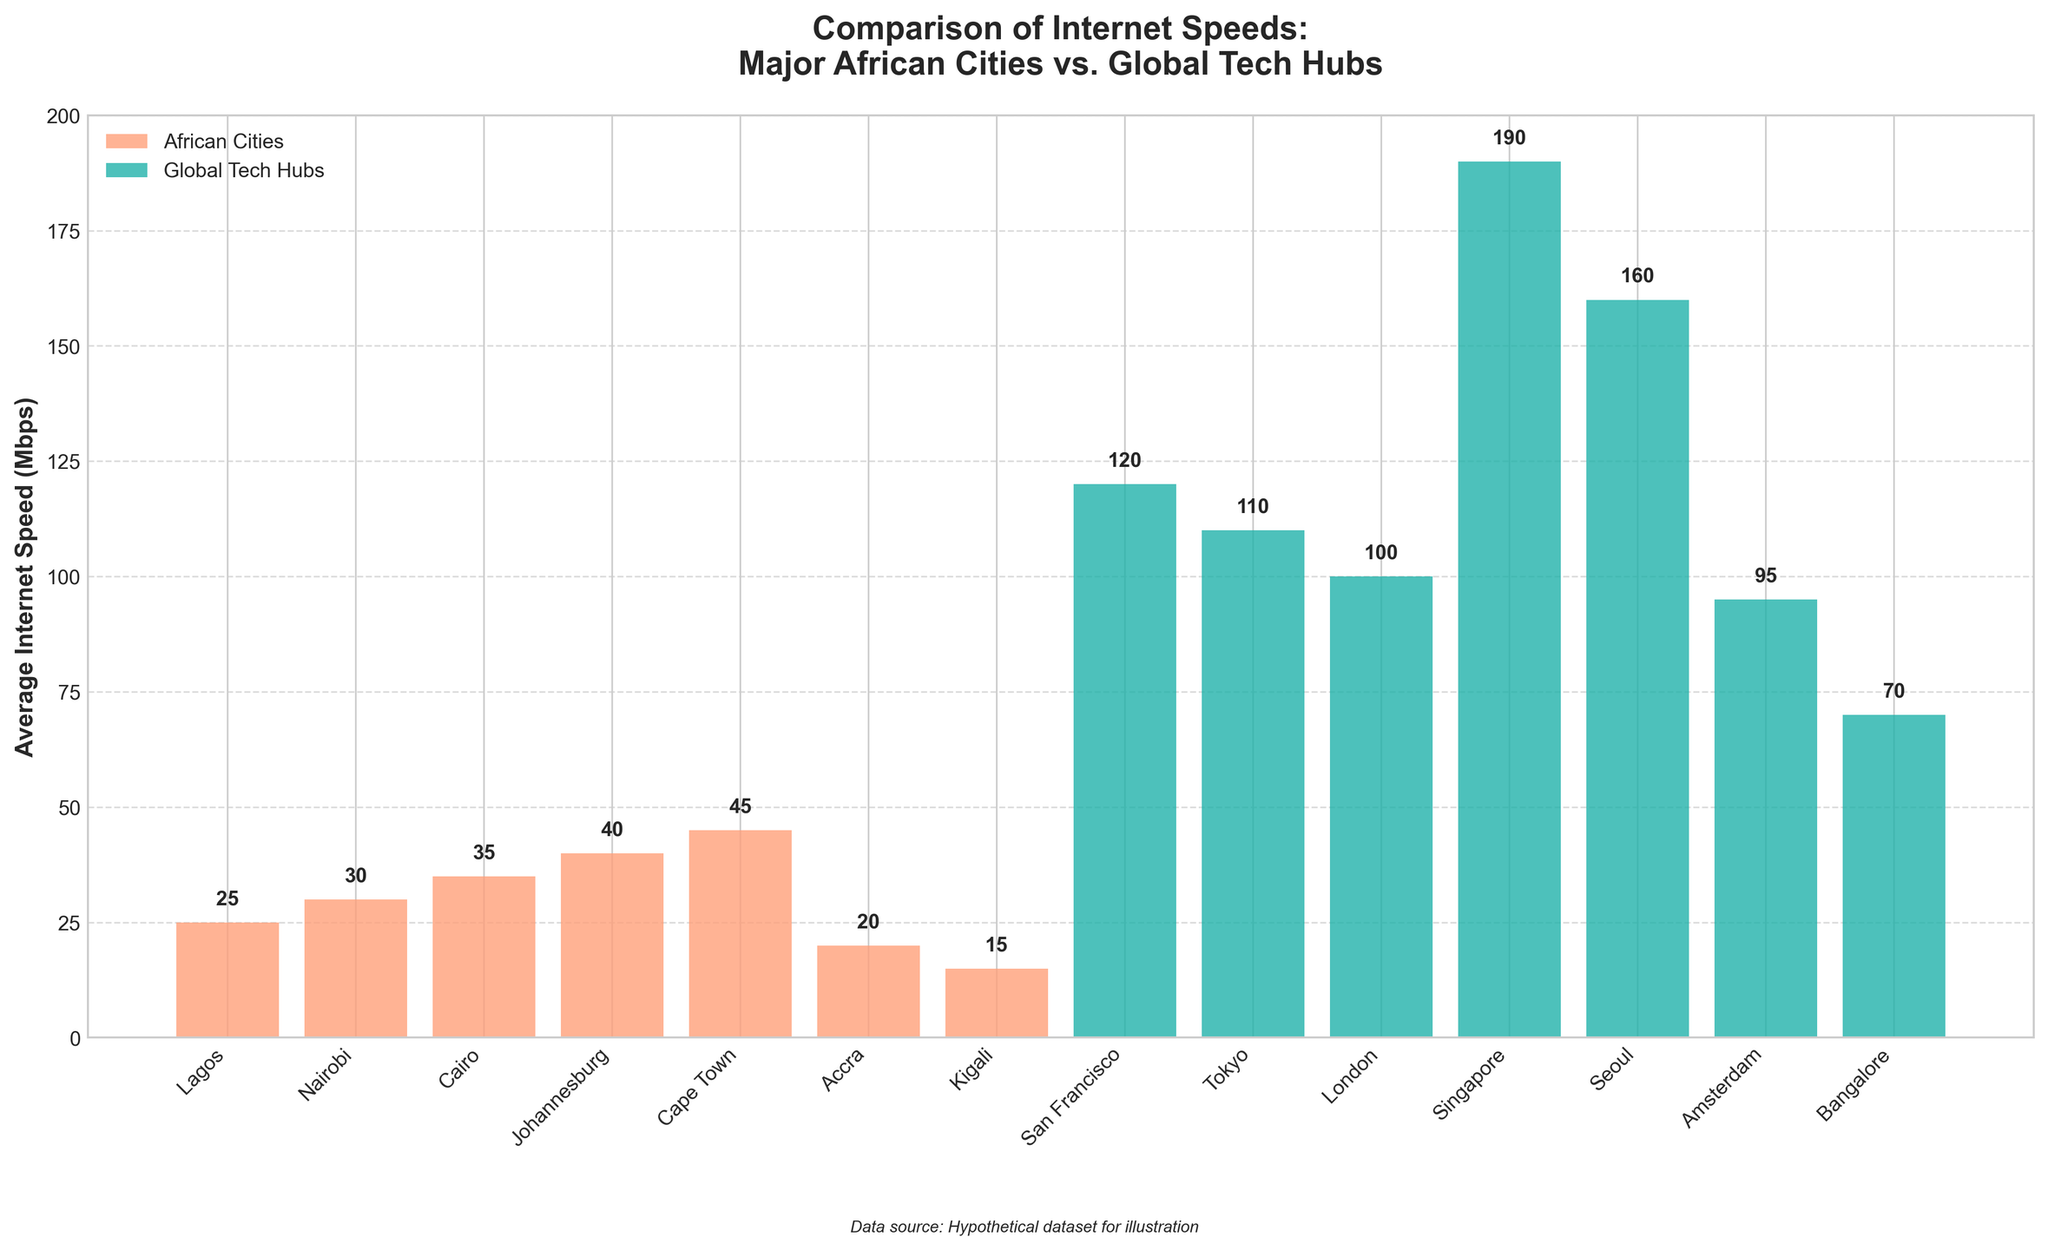What's the average internet speed for African cities shown in the chart? There are 7 African cities with internet speeds of 25, 30, 35, 40, 45, 20, and 15 Mbps. Summing these values gives 25 + 30 + 35 + 40 + 45 + 20 + 15 = 210. Dividing this by the number of cities (7) gives an average of 210/7 = 30 Mbps.
Answer: 30 Mbps Which city has the highest internet speed among the African cities shown? The bar representing Cape Town is taller than the bars for all other African cities. This indicates Cape Town has the highest internet speed among the African cities listed.
Answer: Cape Town How does the internet speed in Lagos compare to that in Tokyo? The height of the bar for Lagos (25 Mbps) is much shorter compared to Tokyo (110 Mbps), indicating Lagos has a significantly lower internet speed than Tokyo.
Answer: Lagos has a lower speed What's the combined internet speed of San Francisco and Singapore? San Francisco has a speed of 120 Mbps, and Singapore has a speed of 190 Mbps. Combining these gives 120 + 190 = 310 Mbps.
Answer: 310 Mbps Which global tech hub has the lowest internet speed? The bar for Amsterdam is the shortest among the global tech hubs, indicating Amsterdam has the lowest internet speed in this group.
Answer: Amsterdam What's the total internet speed for all cities displayed on the chart? Summing all the internet speeds listed: 25 + 30 + 35 + 40 + 45 + 20 + 15 + 120 + 110 + 100 + 190 + 160 + 95 + 70 = 1055 Mbps.
Answer: 1055 Mbps Which city has exactly double the internet speed of Accra? Accra has an internet speed of 20 Mbps. Cape Town, with an internet speed of 45 Mbps, does not exactly fit, but Johannesburg with 40 Mbps is the closest possible but slightly below exact double. There seems to be a misunderstanding here since no city fits exactly double.
Answer: None exactly Which city displayed has the highest internet speed? The tallest bar on the chart belongs to Singapore, indicating it has the highest internet speed among all cities shown.
Answer: Singapore By how much is Seoul's internet speed greater than Lagos's? Seoul has an internet speed of 160 Mbps, and Lagos has 25 Mbps. The difference is 160 - 25 = 135 Mbps.
Answer: 135 Mbps Among the African cities listed, which one has the lowest internet speed? The shortest bar among the African cities is for Kigali, indicating it has the lowest internet speed in this group.
Answer: Kigali 